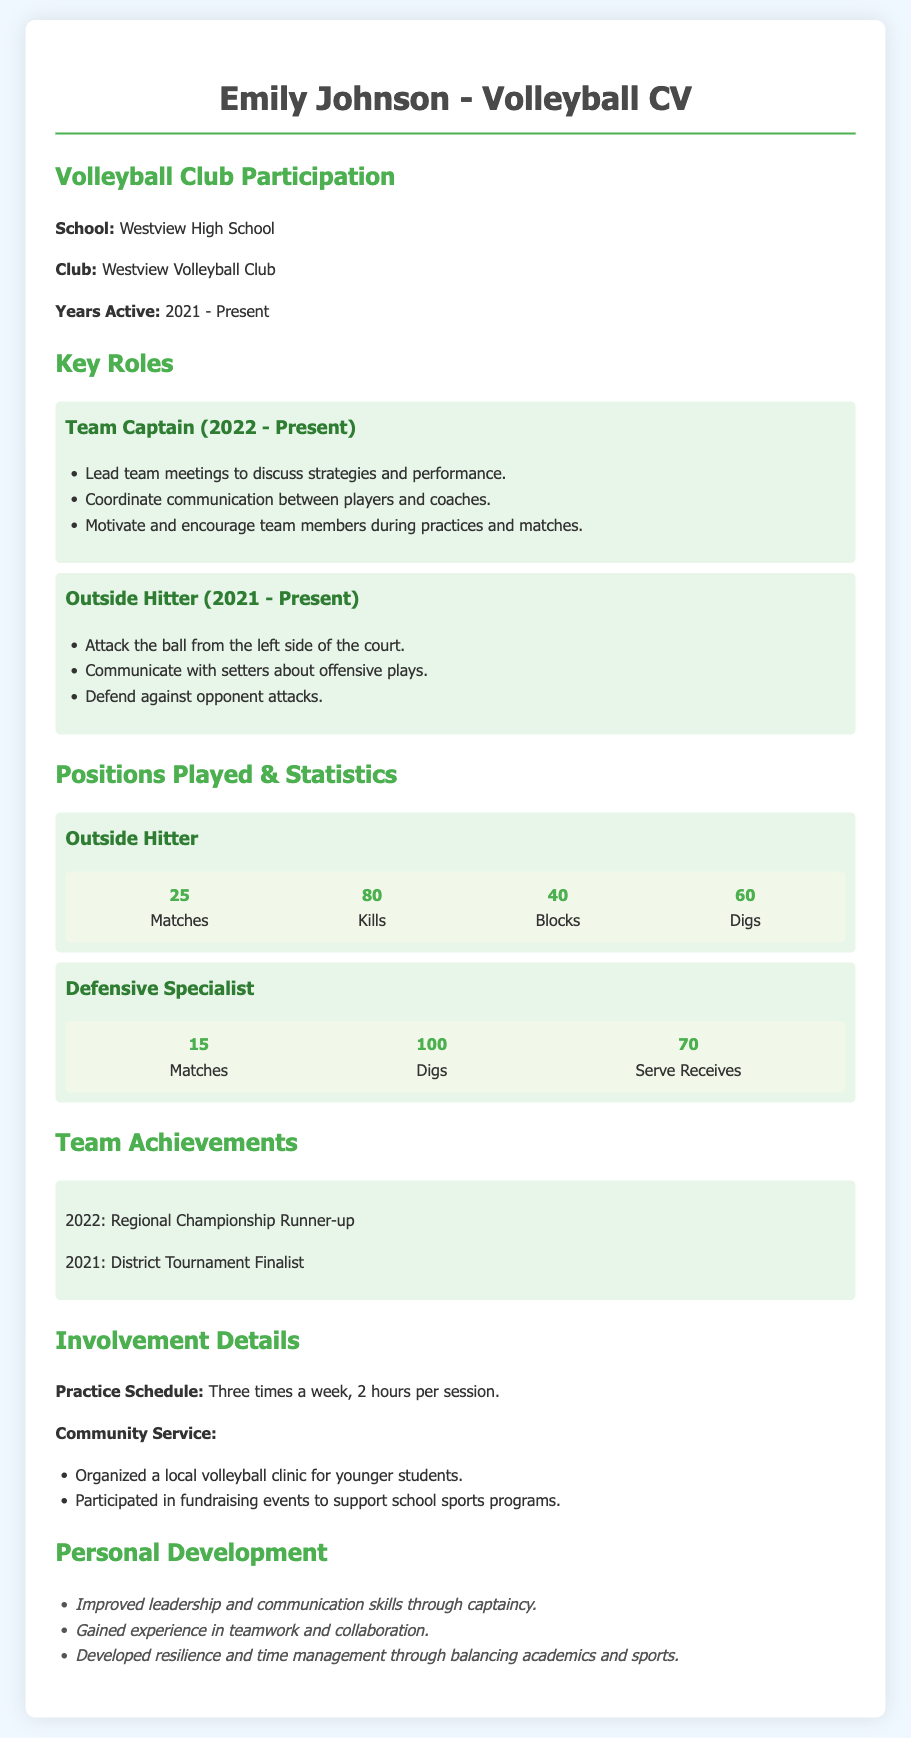What is the name of the school? The document states the school name under Volleyball Club Participation, which is Westview High School.
Answer: Westview High School What position has Emily been playing since 2021? In the Key Roles section, it is mentioned that Emily has been playing as an Outside Hitter since 2021.
Answer: Outside Hitter How many kills does Emily have? In the Positions Played & Statistics section, the document lists 80 kills for Emily.
Answer: 80 How many matches did Emily play as a Defensive Specialist? In the Positions Played & Statistics section, it shows that she played 15 matches as a Defensive Specialist.
Answer: 15 What year was the Regional Championship Runner-up achievement? The Team Achievements section lists the year for this achievement as 2022.
Answer: 2022 What is the practice schedule frequency? The Involvement Details section specifies that practice is held three times a week.
Answer: Three times a week What type of community service was organized? In the Involvement Details section, it is mentioned that Emily organized a local volleyball clinic for younger students.
Answer: Local volleyball clinic What is one personal development skill gained through leadership? The Personal Development section notes improved leadership skills as one of the skills gained.
Answer: Leadership skills 